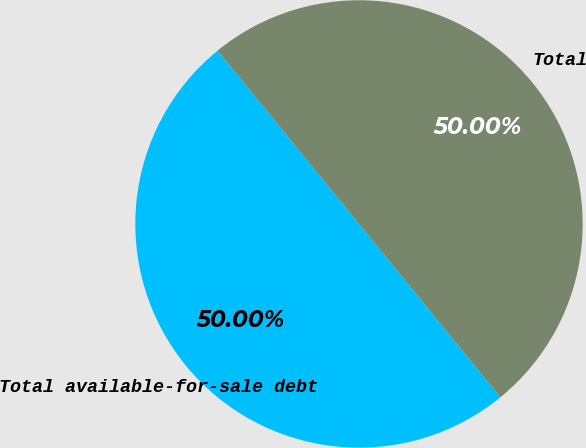Convert chart to OTSL. <chart><loc_0><loc_0><loc_500><loc_500><pie_chart><fcel>Total available-for-sale debt<fcel>Total<nl><fcel>50.0%<fcel>50.0%<nl></chart> 